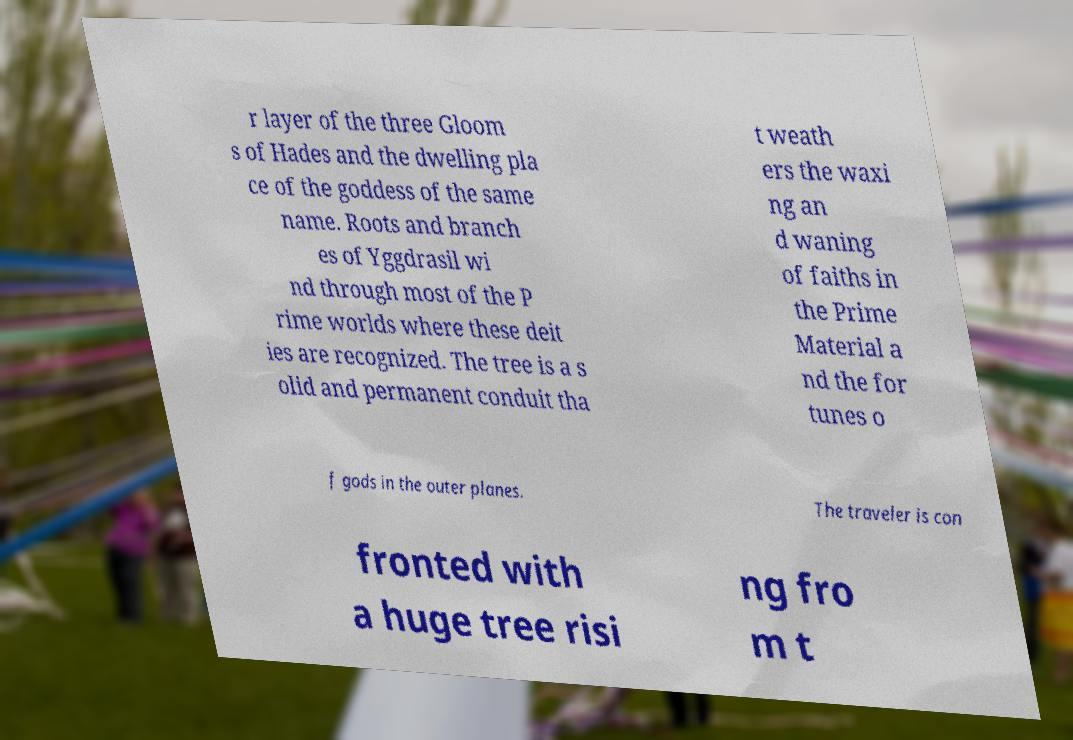I need the written content from this picture converted into text. Can you do that? r layer of the three Gloom s of Hades and the dwelling pla ce of the goddess of the same name. Roots and branch es of Yggdrasil wi nd through most of the P rime worlds where these deit ies are recognized. The tree is a s olid and permanent conduit tha t weath ers the waxi ng an d waning of faiths in the Prime Material a nd the for tunes o f gods in the outer planes. The traveler is con fronted with a huge tree risi ng fro m t 